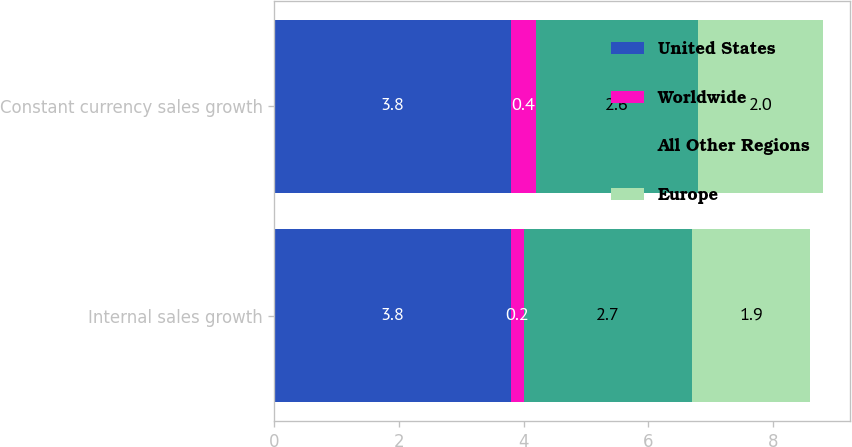<chart> <loc_0><loc_0><loc_500><loc_500><stacked_bar_chart><ecel><fcel>Internal sales growth<fcel>Constant currency sales growth<nl><fcel>United States<fcel>3.8<fcel>3.8<nl><fcel>Worldwide<fcel>0.2<fcel>0.4<nl><fcel>All Other Regions<fcel>2.7<fcel>2.6<nl><fcel>Europe<fcel>1.9<fcel>2<nl></chart> 